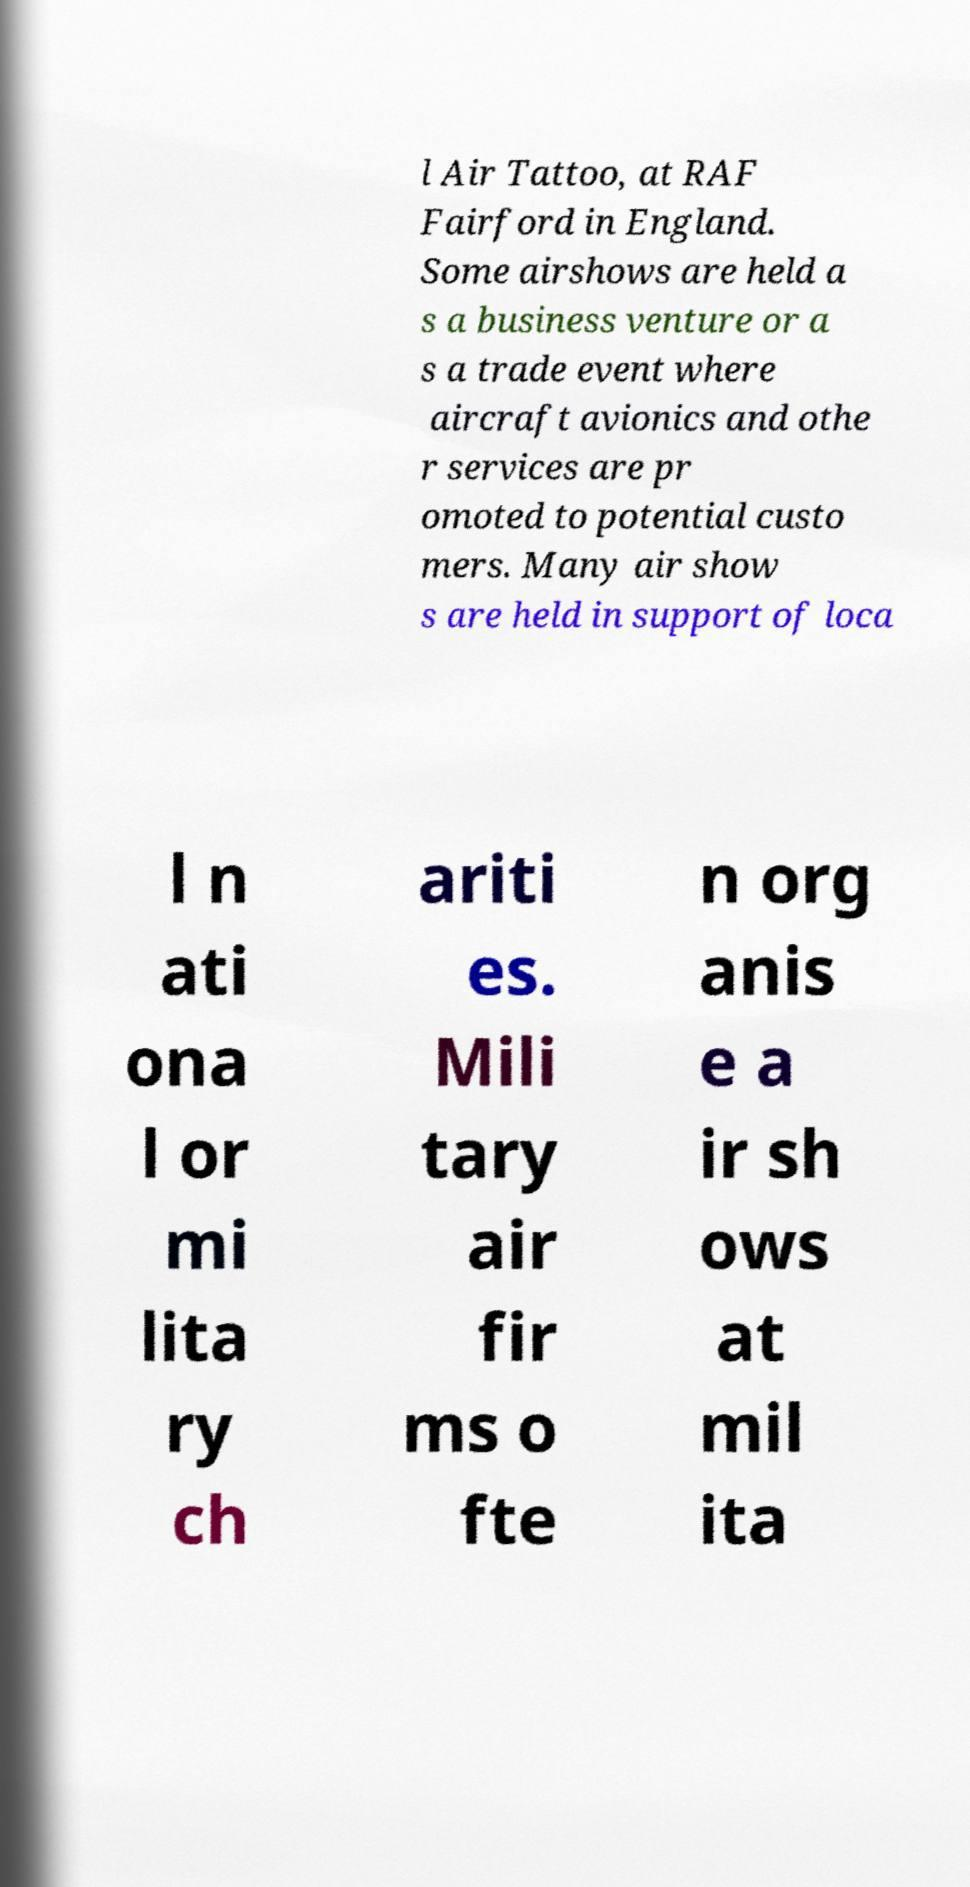There's text embedded in this image that I need extracted. Can you transcribe it verbatim? l Air Tattoo, at RAF Fairford in England. Some airshows are held a s a business venture or a s a trade event where aircraft avionics and othe r services are pr omoted to potential custo mers. Many air show s are held in support of loca l n ati ona l or mi lita ry ch ariti es. Mili tary air fir ms o fte n org anis e a ir sh ows at mil ita 